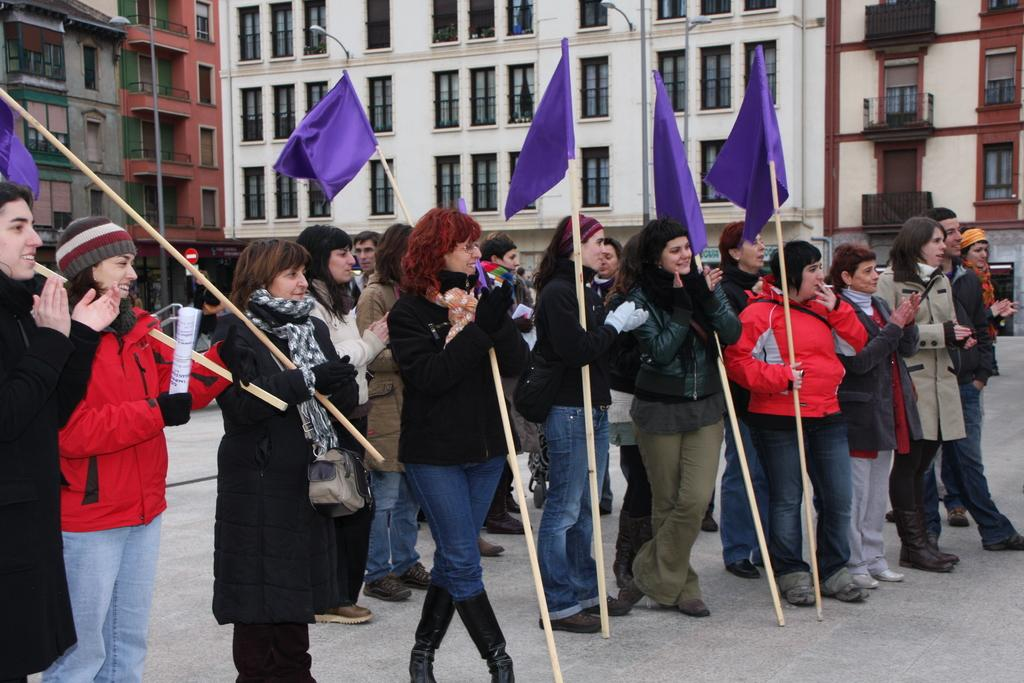What are the people in the image holding? The people in the image are holding flags. What can be seen in the background of the image? There are buildings in the background of the image. What type of egg is being used to communicate in the image? There is no egg present in the image, and therefore it cannot be used for communication. 